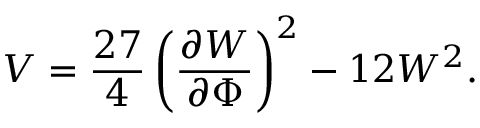<formula> <loc_0><loc_0><loc_500><loc_500>V = \frac { 2 7 } { 4 } \left ( \frac { \partial W } { \partial \Phi } \right ) ^ { 2 } - 1 2 W ^ { 2 } .</formula> 